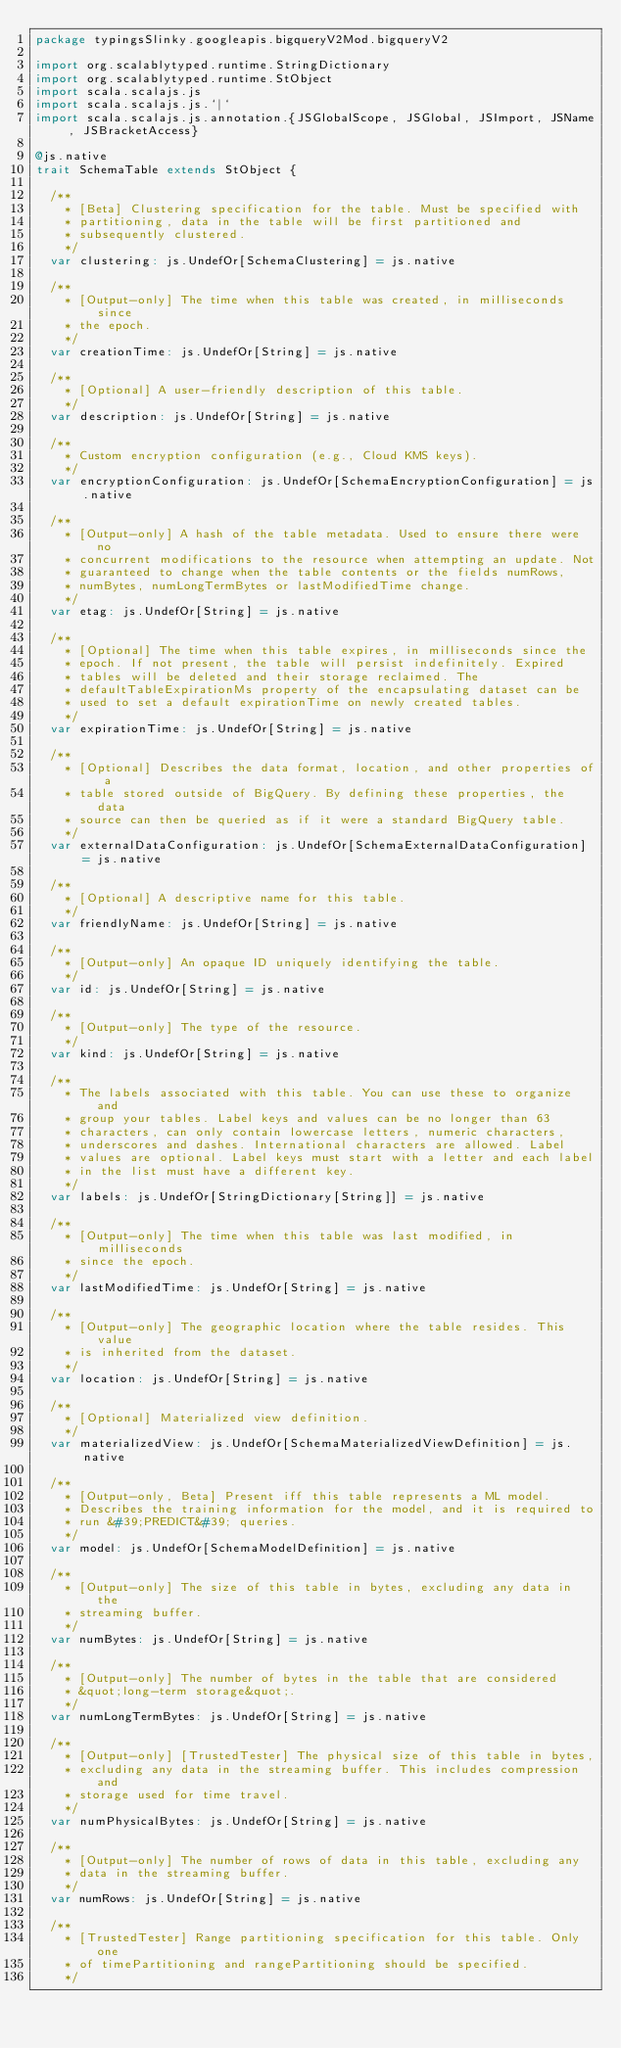Convert code to text. <code><loc_0><loc_0><loc_500><loc_500><_Scala_>package typingsSlinky.googleapis.bigqueryV2Mod.bigqueryV2

import org.scalablytyped.runtime.StringDictionary
import org.scalablytyped.runtime.StObject
import scala.scalajs.js
import scala.scalajs.js.`|`
import scala.scalajs.js.annotation.{JSGlobalScope, JSGlobal, JSImport, JSName, JSBracketAccess}

@js.native
trait SchemaTable extends StObject {
  
  /**
    * [Beta] Clustering specification for the table. Must be specified with
    * partitioning, data in the table will be first partitioned and
    * subsequently clustered.
    */
  var clustering: js.UndefOr[SchemaClustering] = js.native
  
  /**
    * [Output-only] The time when this table was created, in milliseconds since
    * the epoch.
    */
  var creationTime: js.UndefOr[String] = js.native
  
  /**
    * [Optional] A user-friendly description of this table.
    */
  var description: js.UndefOr[String] = js.native
  
  /**
    * Custom encryption configuration (e.g., Cloud KMS keys).
    */
  var encryptionConfiguration: js.UndefOr[SchemaEncryptionConfiguration] = js.native
  
  /**
    * [Output-only] A hash of the table metadata. Used to ensure there were no
    * concurrent modifications to the resource when attempting an update. Not
    * guaranteed to change when the table contents or the fields numRows,
    * numBytes, numLongTermBytes or lastModifiedTime change.
    */
  var etag: js.UndefOr[String] = js.native
  
  /**
    * [Optional] The time when this table expires, in milliseconds since the
    * epoch. If not present, the table will persist indefinitely. Expired
    * tables will be deleted and their storage reclaimed. The
    * defaultTableExpirationMs property of the encapsulating dataset can be
    * used to set a default expirationTime on newly created tables.
    */
  var expirationTime: js.UndefOr[String] = js.native
  
  /**
    * [Optional] Describes the data format, location, and other properties of a
    * table stored outside of BigQuery. By defining these properties, the data
    * source can then be queried as if it were a standard BigQuery table.
    */
  var externalDataConfiguration: js.UndefOr[SchemaExternalDataConfiguration] = js.native
  
  /**
    * [Optional] A descriptive name for this table.
    */
  var friendlyName: js.UndefOr[String] = js.native
  
  /**
    * [Output-only] An opaque ID uniquely identifying the table.
    */
  var id: js.UndefOr[String] = js.native
  
  /**
    * [Output-only] The type of the resource.
    */
  var kind: js.UndefOr[String] = js.native
  
  /**
    * The labels associated with this table. You can use these to organize and
    * group your tables. Label keys and values can be no longer than 63
    * characters, can only contain lowercase letters, numeric characters,
    * underscores and dashes. International characters are allowed. Label
    * values are optional. Label keys must start with a letter and each label
    * in the list must have a different key.
    */
  var labels: js.UndefOr[StringDictionary[String]] = js.native
  
  /**
    * [Output-only] The time when this table was last modified, in milliseconds
    * since the epoch.
    */
  var lastModifiedTime: js.UndefOr[String] = js.native
  
  /**
    * [Output-only] The geographic location where the table resides. This value
    * is inherited from the dataset.
    */
  var location: js.UndefOr[String] = js.native
  
  /**
    * [Optional] Materialized view definition.
    */
  var materializedView: js.UndefOr[SchemaMaterializedViewDefinition] = js.native
  
  /**
    * [Output-only, Beta] Present iff this table represents a ML model.
    * Describes the training information for the model, and it is required to
    * run &#39;PREDICT&#39; queries.
    */
  var model: js.UndefOr[SchemaModelDefinition] = js.native
  
  /**
    * [Output-only] The size of this table in bytes, excluding any data in the
    * streaming buffer.
    */
  var numBytes: js.UndefOr[String] = js.native
  
  /**
    * [Output-only] The number of bytes in the table that are considered
    * &quot;long-term storage&quot;.
    */
  var numLongTermBytes: js.UndefOr[String] = js.native
  
  /**
    * [Output-only] [TrustedTester] The physical size of this table in bytes,
    * excluding any data in the streaming buffer. This includes compression and
    * storage used for time travel.
    */
  var numPhysicalBytes: js.UndefOr[String] = js.native
  
  /**
    * [Output-only] The number of rows of data in this table, excluding any
    * data in the streaming buffer.
    */
  var numRows: js.UndefOr[String] = js.native
  
  /**
    * [TrustedTester] Range partitioning specification for this table. Only one
    * of timePartitioning and rangePartitioning should be specified.
    */</code> 